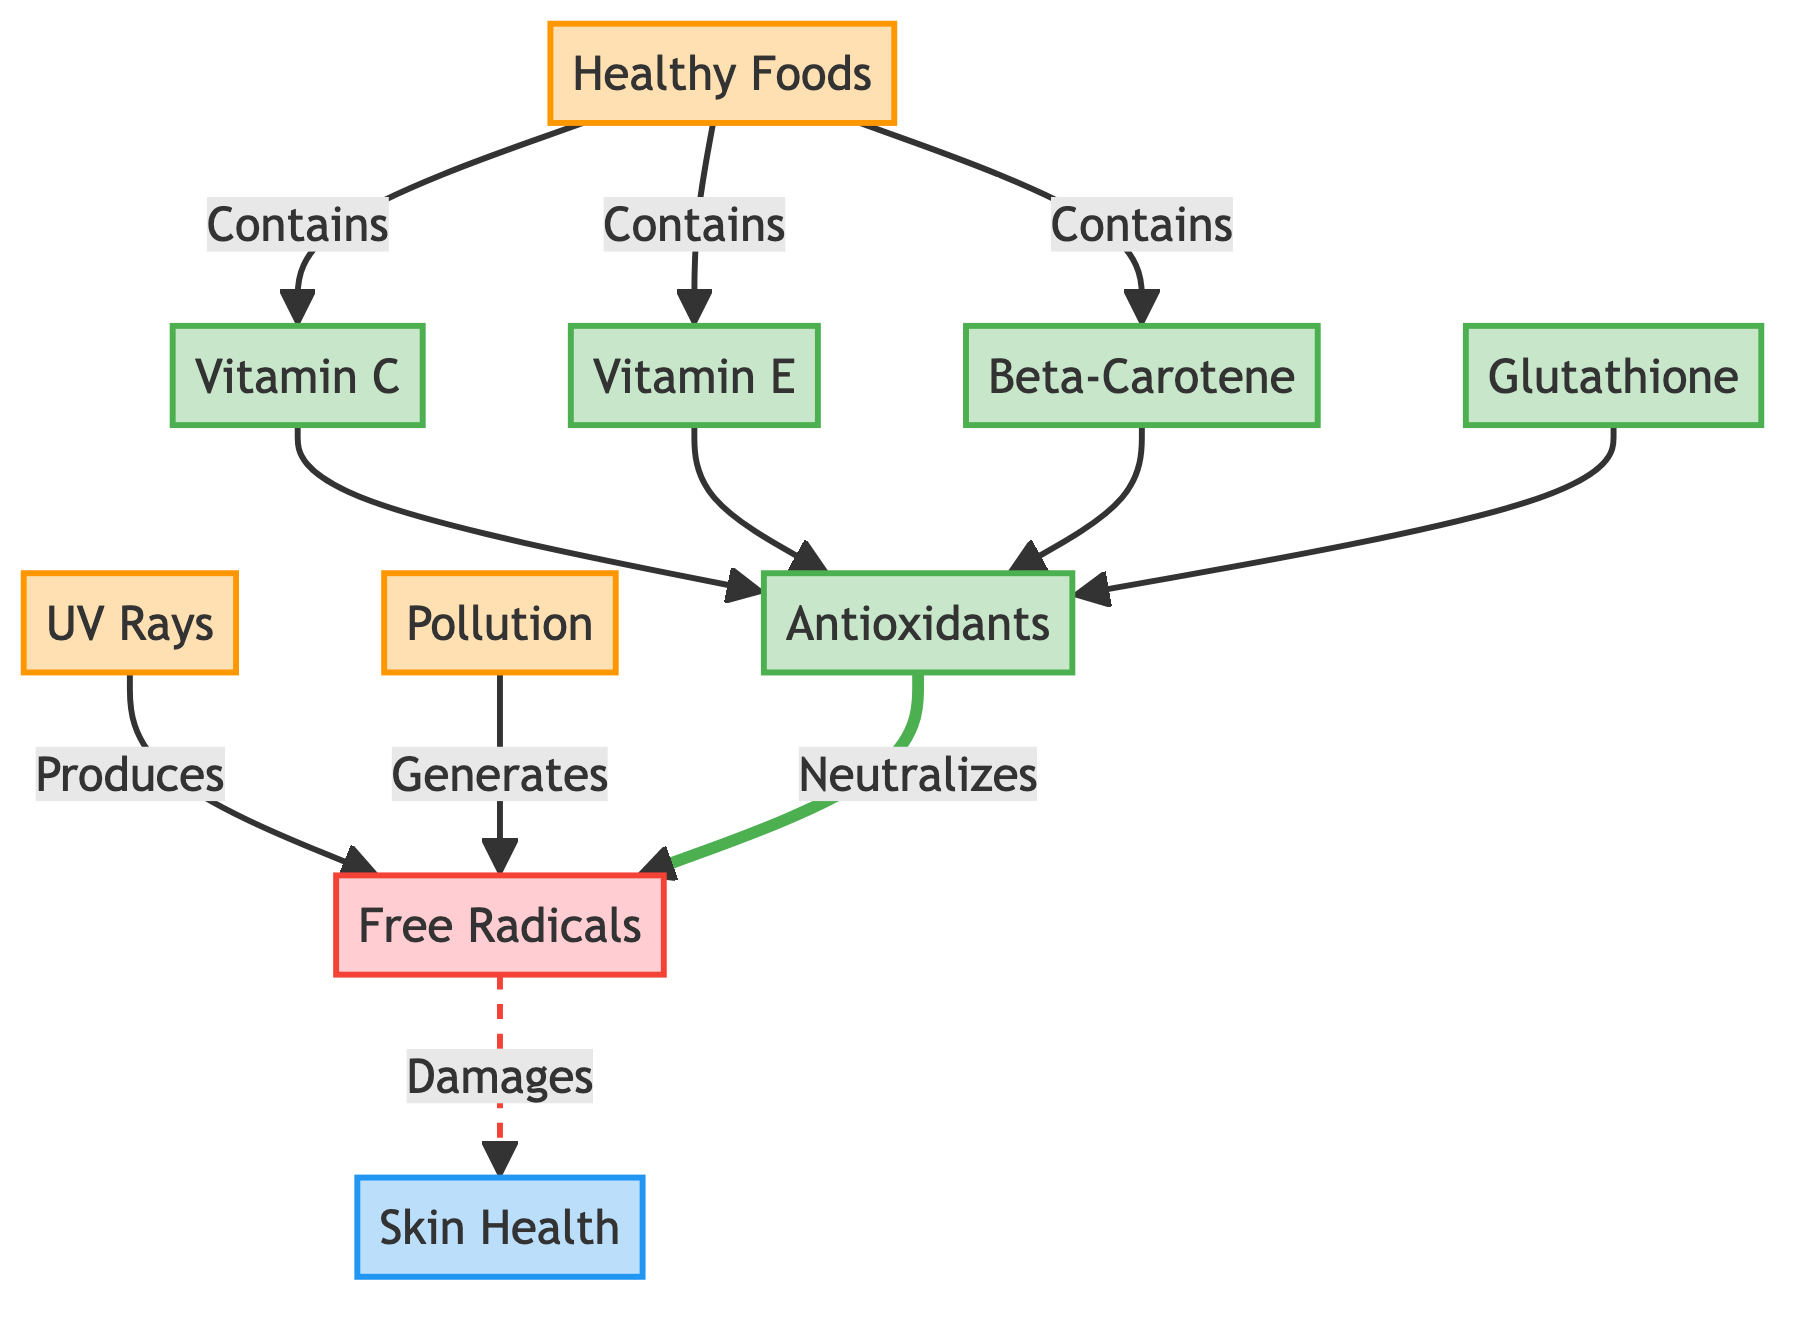What are the sources of free radicals in the diagram? The diagram identifies two sources of free radicals, UV Rays and Pollution, both depicted as nodes connected to the Free Radicals node.
Answer: UV Rays, Pollution How many types of antioxidants are shown in the diagram? The diagram lists four specific types of antioxidants: Vitamin C, Vitamin E, Beta-Carotene, and Glutathione. Each is individually represented as a node.
Answer: 4 What do antioxidants neutralize in the diagram? The diagram shows that antioxidants are directly linked to the Free Radicals node indicating that antioxidants neutralize free radicals.
Answer: Free Radicals How do healthy foods relate to antioxidants? The diagram indicates that healthy foods contain Vitamin C, Vitamin E, and Beta-Carotene, which contribute to the Antioxidants node. This shows the indirect pathway that healthy foods take to influence antioxidant levels.
Answer: Contains What happens to skin health when free radicals are present? The diagram shows a dashed line from Free Radicals to Skin Health, indicating that free radicals damage skin health through that connection.
Answer: Damages Which factors are sources in the diagram? The diagram lists Healthy Foods, UV Rays, and Pollution as sources; each is clearly identified and connected to their respective nodes.
Answer: Healthy Foods, UV Rays, Pollution How do antioxidants contribute to skin health? Antioxidants are shown to neutralize free radicals, which in turn leads to improved skin health. This relationship indicates a beneficial effect on skin health when antioxidants are present.
Answer: Neutralizes Which antioxidant is not derived from healthy foods according to the diagram? The diagram shows that Glutathione is listed as an antioxidant, but there is no direct link indicating it comes from healthy foods, whereas the other three antioxidants are directly associated with healthy foods.
Answer: Glutathione 